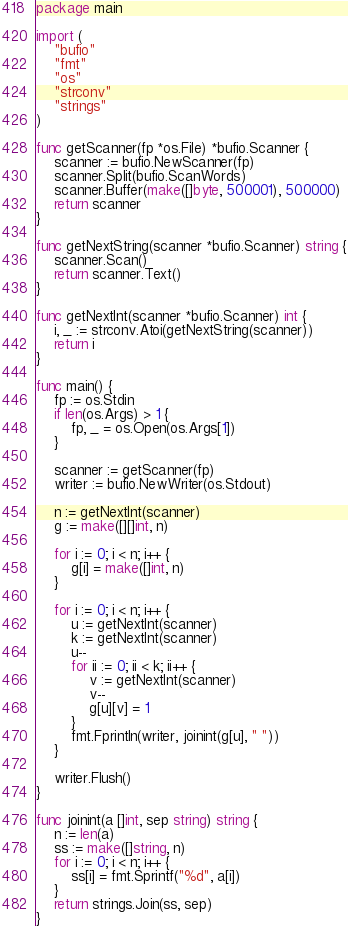<code> <loc_0><loc_0><loc_500><loc_500><_Go_>package main

import (
	"bufio"
	"fmt"
	"os"
	"strconv"
	"strings"
)

func getScanner(fp *os.File) *bufio.Scanner {
	scanner := bufio.NewScanner(fp)
	scanner.Split(bufio.ScanWords)
	scanner.Buffer(make([]byte, 500001), 500000)
	return scanner
}

func getNextString(scanner *bufio.Scanner) string {
	scanner.Scan()
	return scanner.Text()
}

func getNextInt(scanner *bufio.Scanner) int {
	i, _ := strconv.Atoi(getNextString(scanner))
	return i
}

func main() {
	fp := os.Stdin
	if len(os.Args) > 1 {
		fp, _ = os.Open(os.Args[1])
	}

	scanner := getScanner(fp)
	writer := bufio.NewWriter(os.Stdout)

	n := getNextInt(scanner)
	g := make([][]int, n)

	for i := 0; i < n; i++ {
		g[i] = make([]int, n)
	}

	for i := 0; i < n; i++ {
		u := getNextInt(scanner)
		k := getNextInt(scanner)
		u--
		for ii := 0; ii < k; ii++ {
			v := getNextInt(scanner)
			v--
			g[u][v] = 1
		}
		fmt.Fprintln(writer, joinint(g[u], " "))
	}

	writer.Flush()
}

func joinint(a []int, sep string) string {
	n := len(a)
	ss := make([]string, n)
	for i := 0; i < n; i++ {
		ss[i] = fmt.Sprintf("%d", a[i])
	}
	return strings.Join(ss, sep)
}

</code> 